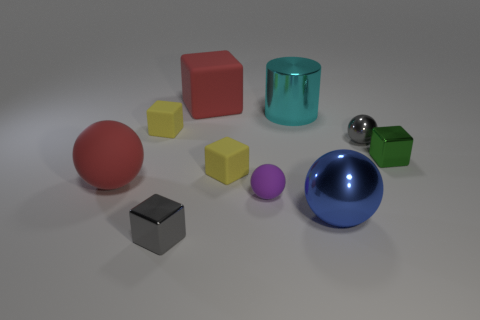Is the color of the cube behind the big cyan shiny thing the same as the large rubber ball?
Your answer should be compact. Yes. What number of other objects are there of the same color as the large block?
Keep it short and to the point. 1. Do the large matte sphere and the big matte block have the same color?
Give a very brief answer. Yes. There is a block that is the same color as the tiny metallic sphere; what material is it?
Offer a very short reply. Metal. There is a gray ball; are there any gray spheres to the left of it?
Make the answer very short. No. There is a small purple matte thing; is it the same shape as the large red matte object that is to the left of the big rubber cube?
Provide a short and direct response. Yes. What is the color of the other sphere that is made of the same material as the tiny purple ball?
Offer a terse response. Red. The large metal cylinder has what color?
Ensure brevity in your answer.  Cyan. Are the small purple sphere and the big sphere that is on the right side of the cyan metallic thing made of the same material?
Offer a terse response. No. How many small cubes are to the right of the large cyan cylinder and left of the small green metallic thing?
Offer a very short reply. 0. 